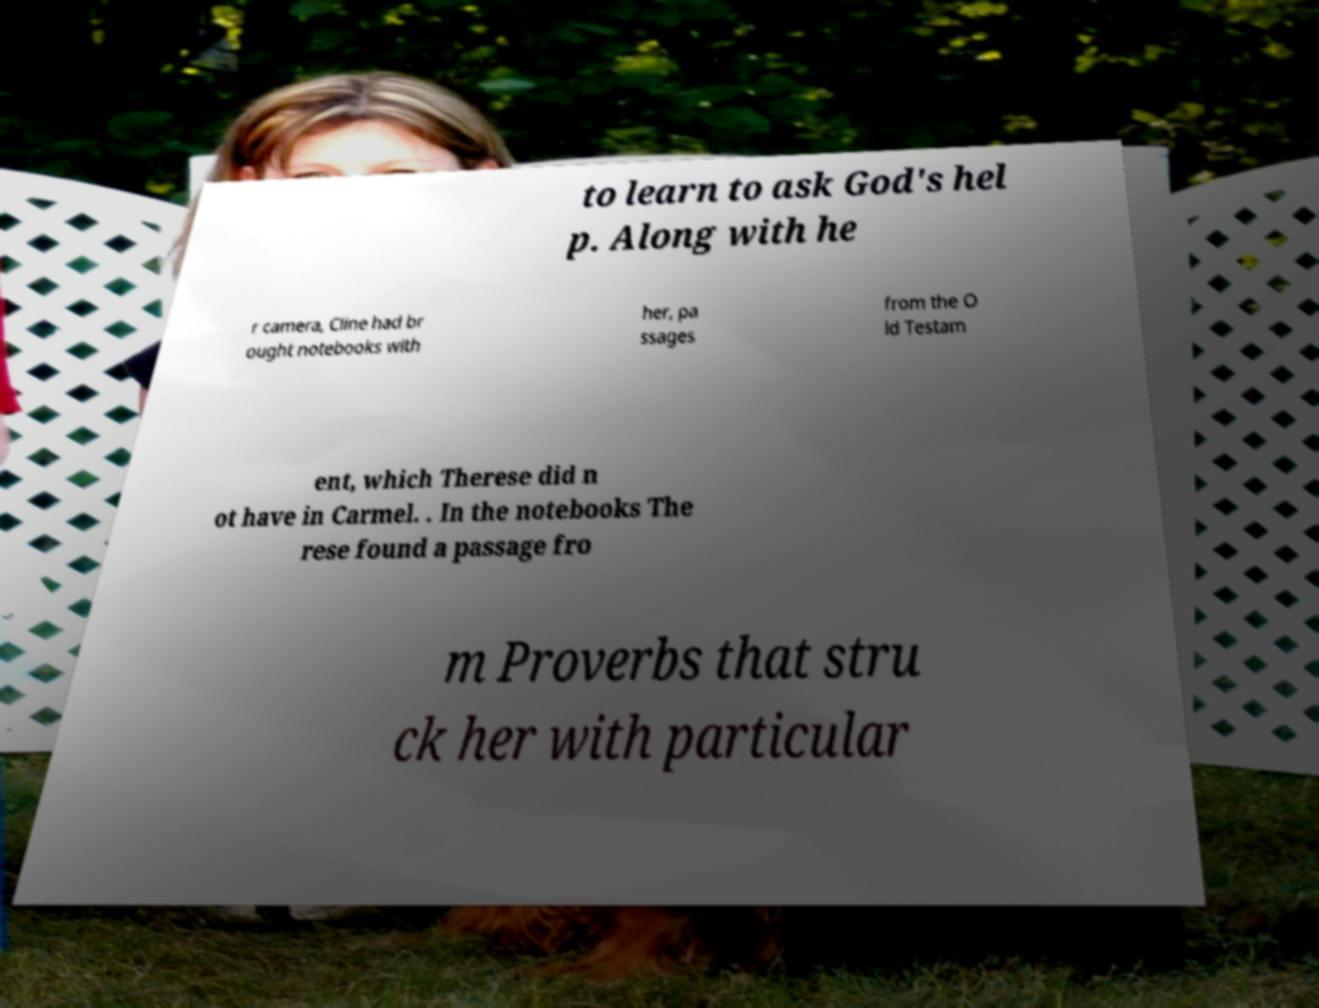There's text embedded in this image that I need extracted. Can you transcribe it verbatim? to learn to ask God's hel p. Along with he r camera, Cline had br ought notebooks with her, pa ssages from the O ld Testam ent, which Therese did n ot have in Carmel. . In the notebooks The rese found a passage fro m Proverbs that stru ck her with particular 